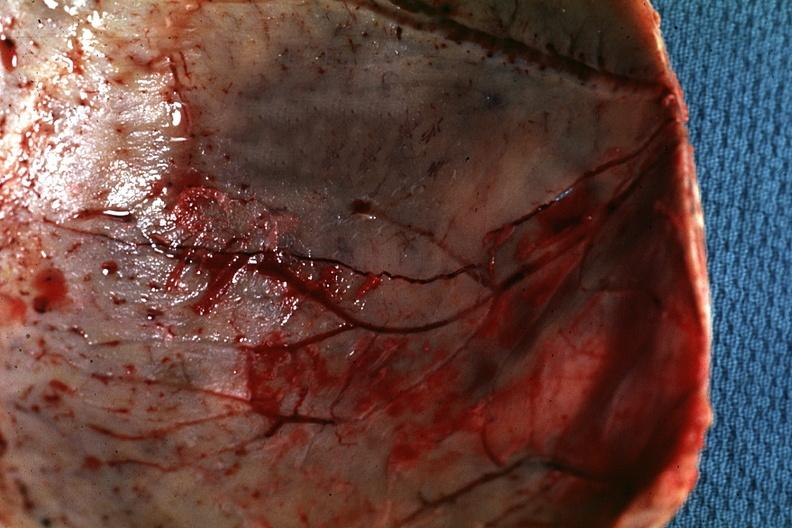what is present?
Answer the question using a single word or phrase. Bone, calvarium 